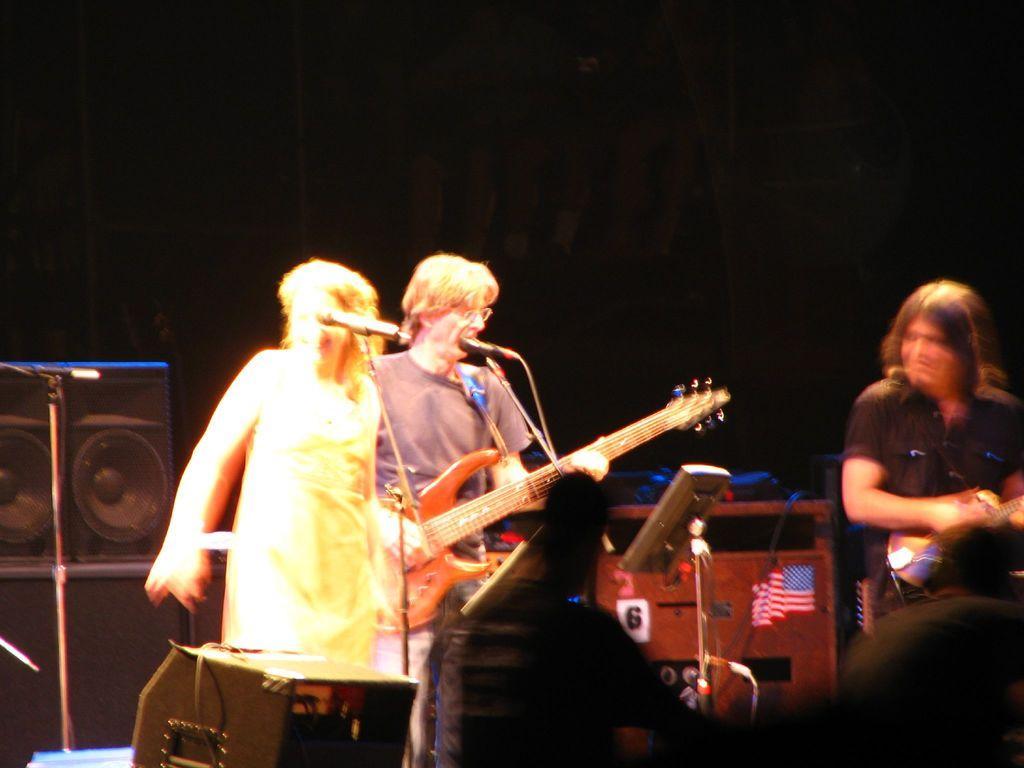How would you summarize this image in a sentence or two? Background is dark. Here we can see speakers and device. These are flags. We can see persons standing in front of a mike and playing guitar. He we can see a woman standing in front of a mike and smiling. At the right side of the picture we can see a person holding a guitar in hands. This is a device. 